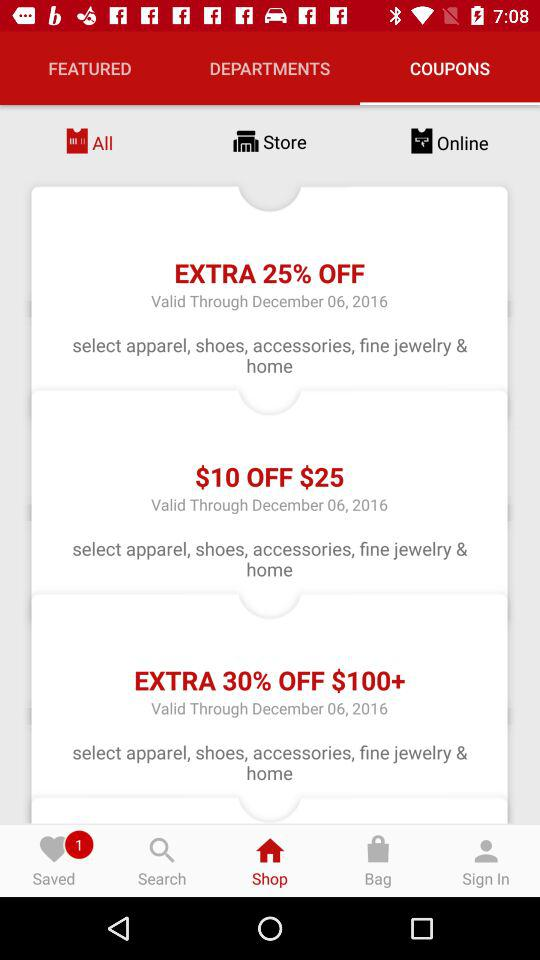How many coupons are displayed?
Answer the question using a single word or phrase. 3 